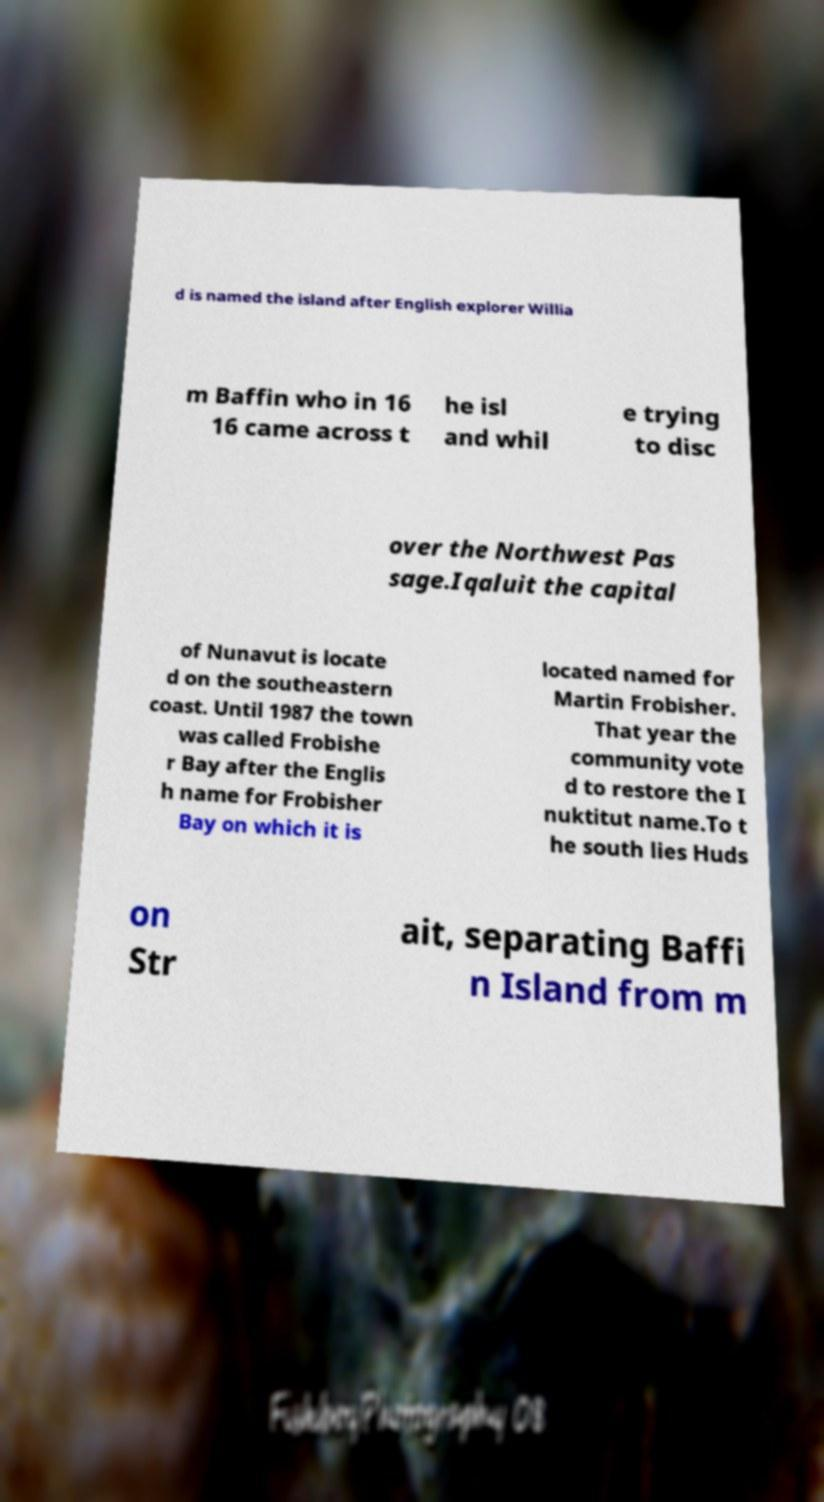Could you extract and type out the text from this image? d is named the island after English explorer Willia m Baffin who in 16 16 came across t he isl and whil e trying to disc over the Northwest Pas sage.Iqaluit the capital of Nunavut is locate d on the southeastern coast. Until 1987 the town was called Frobishe r Bay after the Englis h name for Frobisher Bay on which it is located named for Martin Frobisher. That year the community vote d to restore the I nuktitut name.To t he south lies Huds on Str ait, separating Baffi n Island from m 